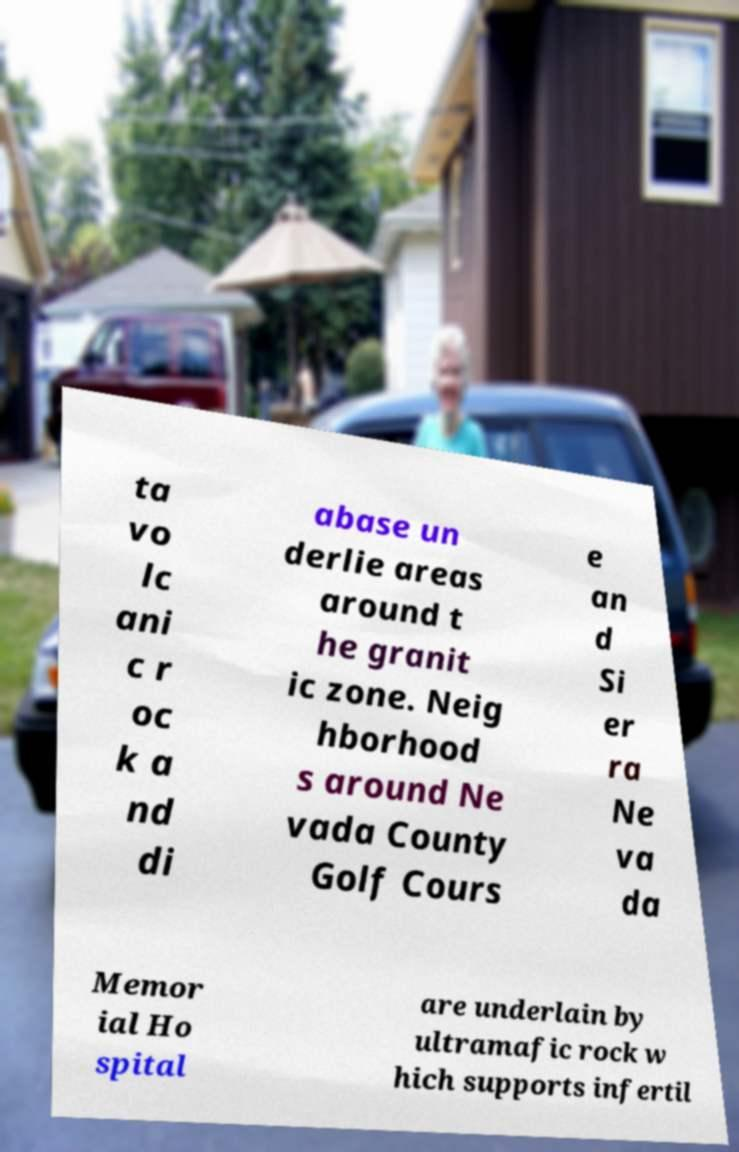Could you assist in decoding the text presented in this image and type it out clearly? ta vo lc ani c r oc k a nd di abase un derlie areas around t he granit ic zone. Neig hborhood s around Ne vada County Golf Cours e an d Si er ra Ne va da Memor ial Ho spital are underlain by ultramafic rock w hich supports infertil 